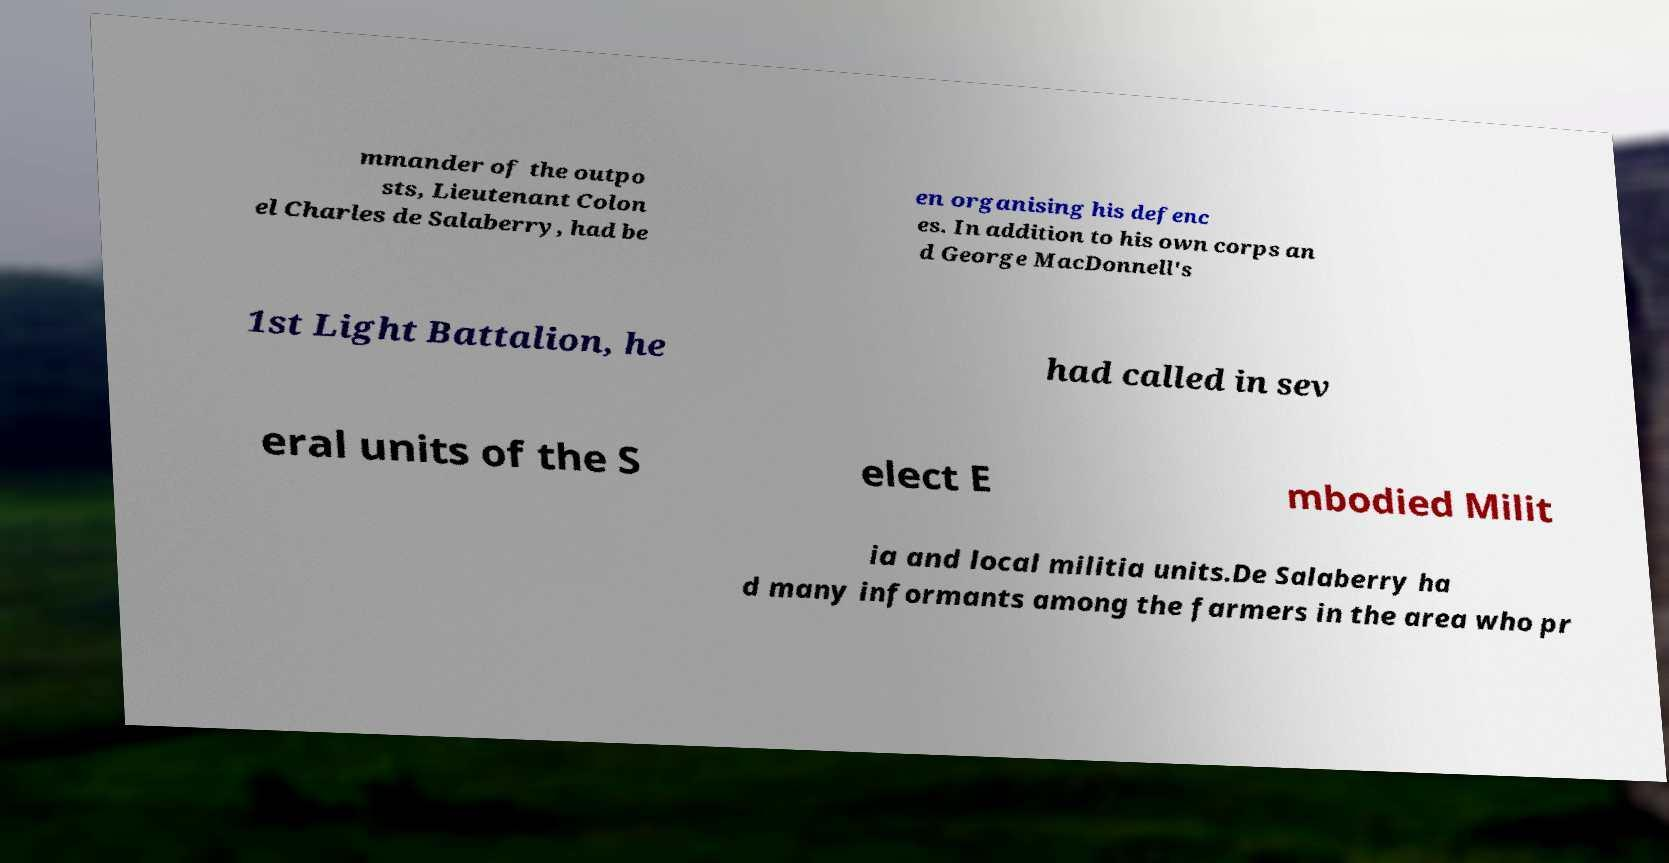Please read and relay the text visible in this image. What does it say? mmander of the outpo sts, Lieutenant Colon el Charles de Salaberry, had be en organising his defenc es. In addition to his own corps an d George MacDonnell's 1st Light Battalion, he had called in sev eral units of the S elect E mbodied Milit ia and local militia units.De Salaberry ha d many informants among the farmers in the area who pr 